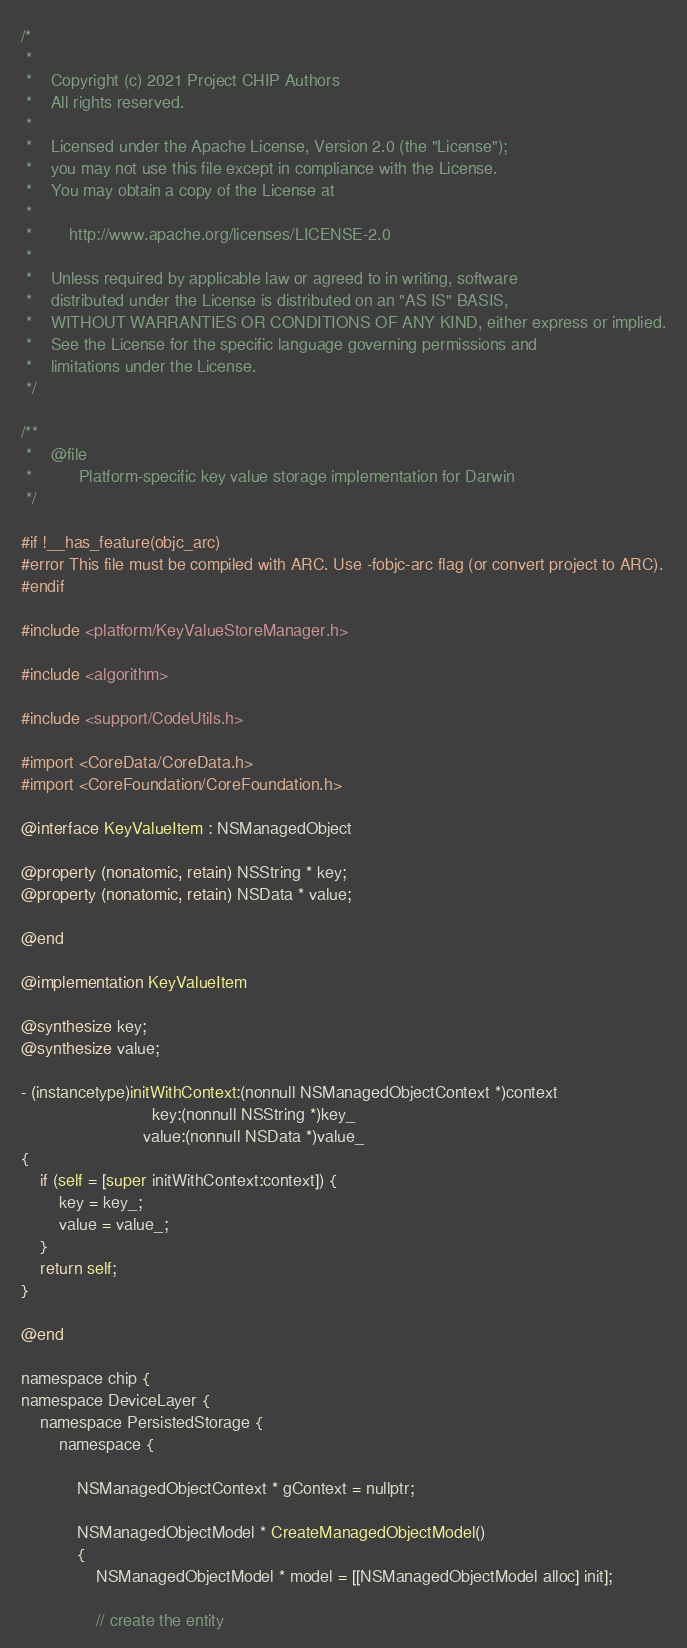Convert code to text. <code><loc_0><loc_0><loc_500><loc_500><_ObjectiveC_>/*
 *
 *    Copyright (c) 2021 Project CHIP Authors
 *    All rights reserved.
 *
 *    Licensed under the Apache License, Version 2.0 (the "License");
 *    you may not use this file except in compliance with the License.
 *    You may obtain a copy of the License at
 *
 *        http://www.apache.org/licenses/LICENSE-2.0
 *
 *    Unless required by applicable law or agreed to in writing, software
 *    distributed under the License is distributed on an "AS IS" BASIS,
 *    WITHOUT WARRANTIES OR CONDITIONS OF ANY KIND, either express or implied.
 *    See the License for the specific language governing permissions and
 *    limitations under the License.
 */

/**
 *    @file
 *          Platform-specific key value storage implementation for Darwin
 */

#if !__has_feature(objc_arc)
#error This file must be compiled with ARC. Use -fobjc-arc flag (or convert project to ARC).
#endif

#include <platform/KeyValueStoreManager.h>

#include <algorithm>

#include <support/CodeUtils.h>

#import <CoreData/CoreData.h>
#import <CoreFoundation/CoreFoundation.h>

@interface KeyValueItem : NSManagedObject

@property (nonatomic, retain) NSString * key;
@property (nonatomic, retain) NSData * value;

@end

@implementation KeyValueItem

@synthesize key;
@synthesize value;

- (instancetype)initWithContext:(nonnull NSManagedObjectContext *)context
                            key:(nonnull NSString *)key_
                          value:(nonnull NSData *)value_
{
    if (self = [super initWithContext:context]) {
        key = key_;
        value = value_;
    }
    return self;
}

@end

namespace chip {
namespace DeviceLayer {
    namespace PersistedStorage {
        namespace {

            NSManagedObjectContext * gContext = nullptr;

            NSManagedObjectModel * CreateManagedObjectModel()
            {
                NSManagedObjectModel * model = [[NSManagedObjectModel alloc] init];

                // create the entity</code> 